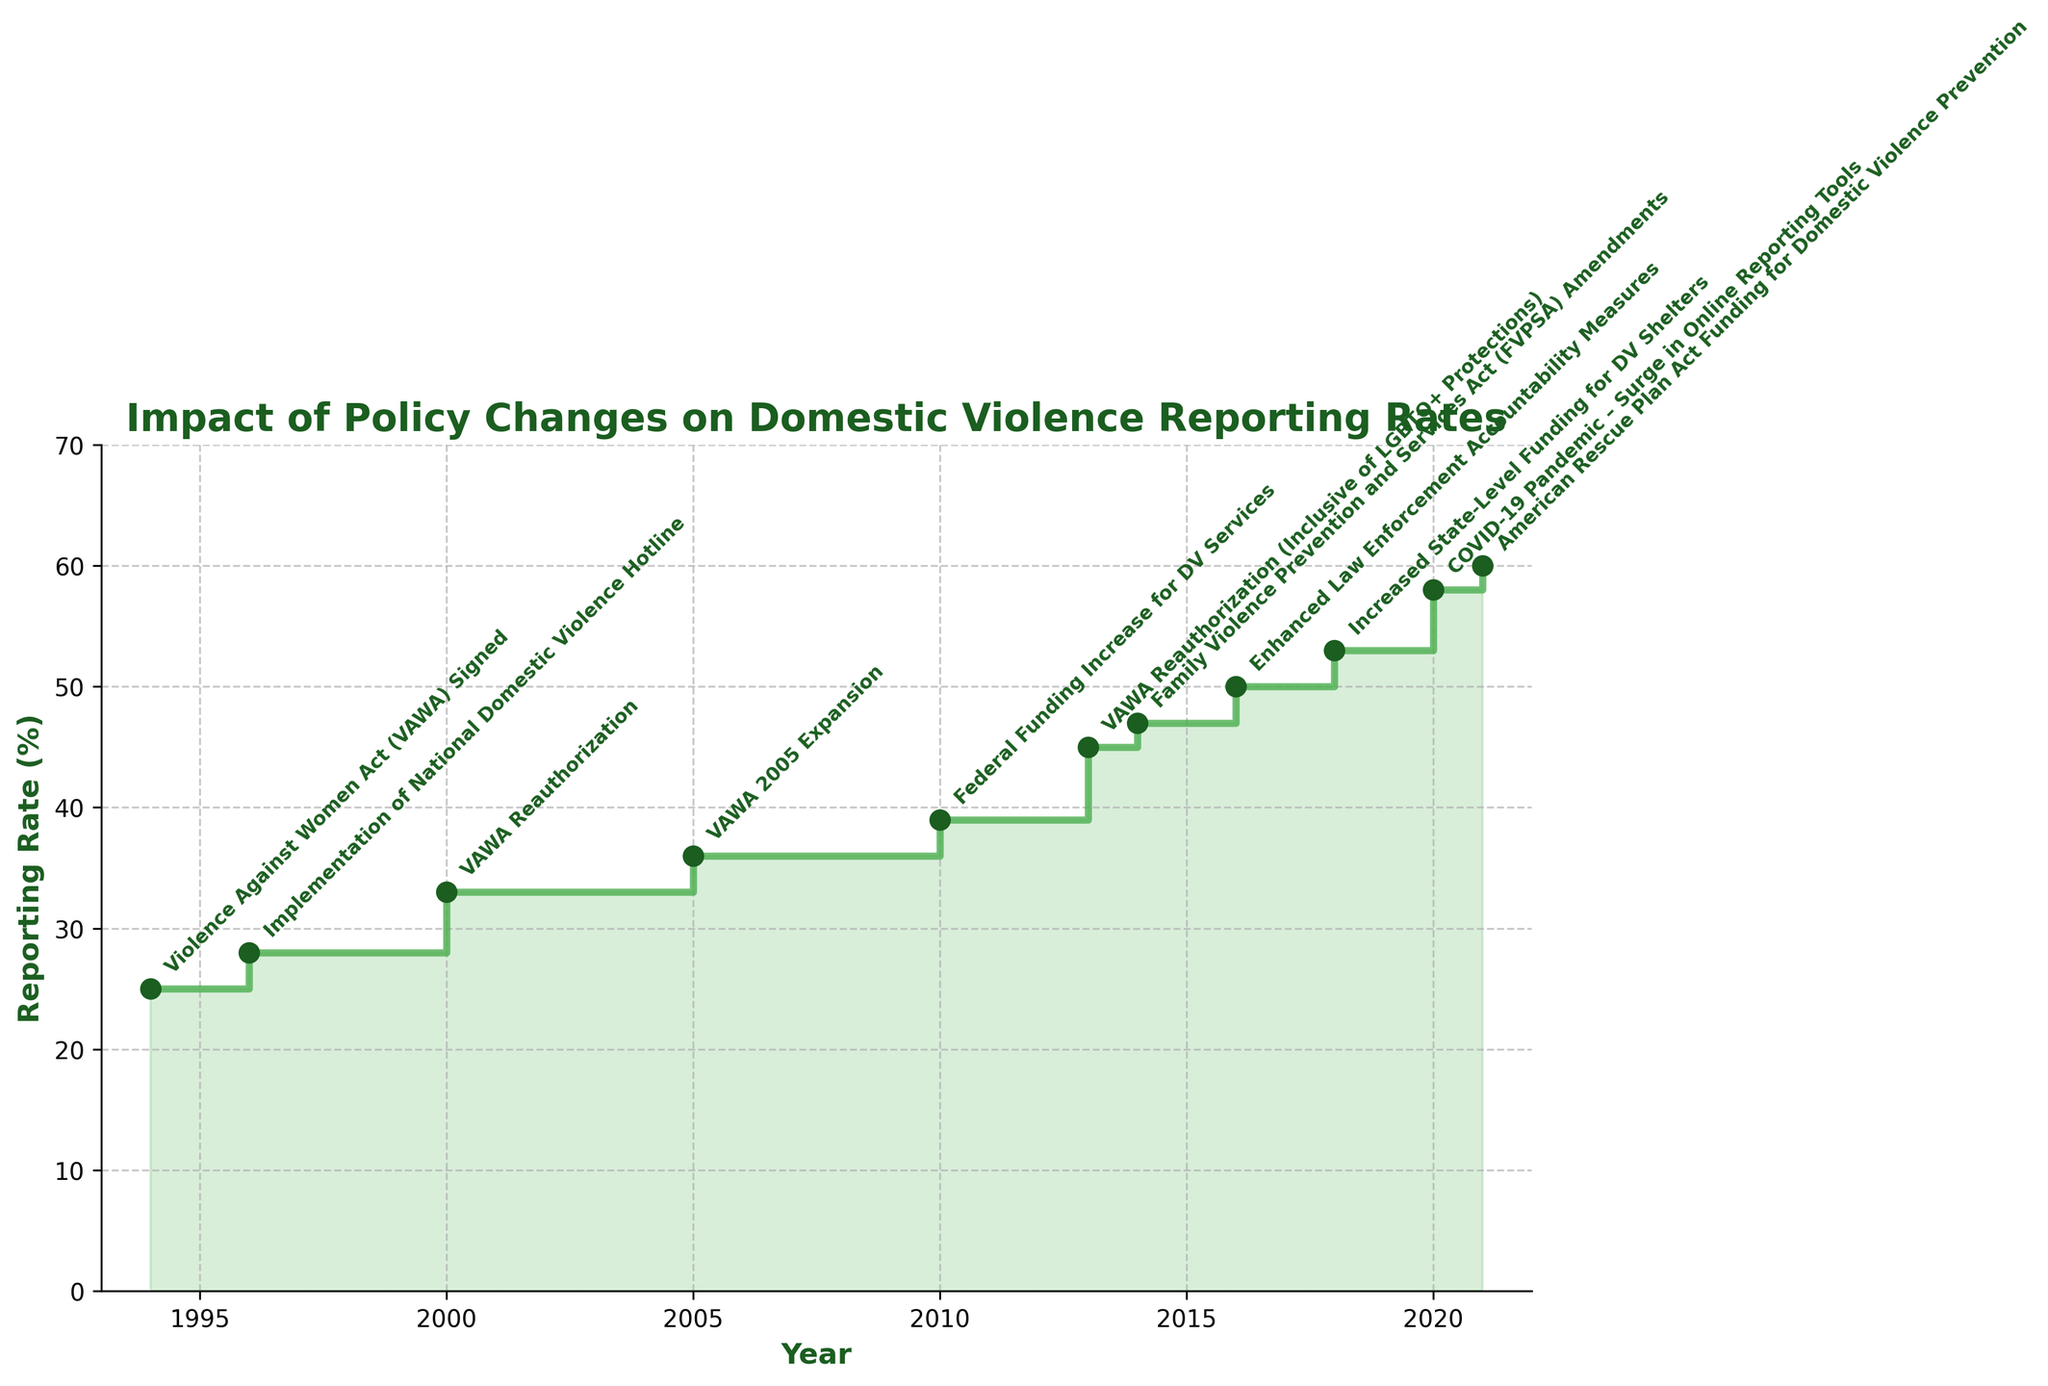What's the highest reporting rate shown in the figure? To find the highest reporting rate, examine the figure and identify the peak of the timeline. The year 2021 has the highest rate marked at 60%.
Answer: 60% What is the title of the figure? The title is typically located at the top center of the figure. In this case, the title is "Impact of Policy Changes on Domestic Violence Reporting Rates".
Answer: Impact of Policy Changes on Domestic Violence Reporting Rates Which policy change corresponds with the highest increase in reporting rate? First, identify which steps in the chart are the steepest, indicating large increases. The transition from 2013 to 2014, with the policy "Family Violence Prevention and Services Act (FVPSA) Amendments", shows a significant increase.
Answer: Family Violence Prevention and Services Act (FVPSA) Amendments How many policy changes are annotated on the figure? Count the distinct annotations for each policy change on the figure. There are 11 policy events marked.
Answer: 11 What was the reporting rate in 1994? Look at the chart's starting point in 1994, marked with the policy "Violence Against Women Act (VAWA) Signed". The corresponding rate is 25%.
Answer: 25% What year had the largest single-year increase in reporting rate? Compare the difference in reporting rates year by year for the largest increment. The increase from 2020 (58%) to 2021 (60%) was the highest single-year increase of 2%.
Answer: 2021 During which periods did the reporting rate remain constant? Look for horizontal sections in the step chart where the rate did not change between two consecutive years. The period between 2000 and 2005 shows constant rates.
Answer: 2000-2005 What was the reporting rate change before and after the VAWA 2005 Expansion? Look at the reporting rate of 2005 and compare it to 2000. The rate increased from 33% in 2000 to 36% in 2005. The difference is 3%.
Answer: 3% How many years after the initial VAWA enactment was the first reauthorization? Locate the initial VAWA enactment in 1994 and the first reauthorization in 2000. The interval between these years is 6.
Answer: 6 Comparing the periods pre- and post-2010, was the reporting rate generally higher or lower? Assess the trend from 1994 to 2010 and compare it with 2010 onward. Post-2010, rates generally show a consistent upward trend. Thus, reporting rates were higher post-2010.
Answer: Higher 